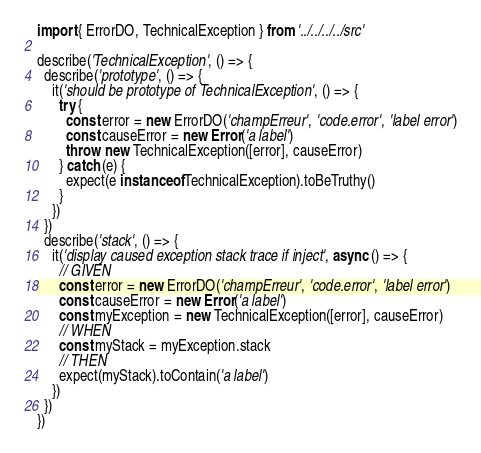<code> <loc_0><loc_0><loc_500><loc_500><_TypeScript_>import { ErrorDO, TechnicalException } from '../../../../src'

describe('TechnicalException', () => {
  describe('prototype', () => {
    it('should be prototype of TechnicalException', () => {
      try {
        const error = new ErrorDO('champErreur', 'code.error', 'label error')
        const causeError = new Error('a label')
        throw  new TechnicalException([error], causeError)
      } catch (e) {
        expect(e instanceof TechnicalException).toBeTruthy()
      }
    })
  })
  describe('stack', () => {
    it('display caused exception stack trace if inject', async () => {
      // GIVEN
      const error = new ErrorDO('champErreur', 'code.error', 'label error')
      const causeError = new Error('a label')
      const myException = new TechnicalException([error], causeError)
      // WHEN
      const myStack = myException.stack
      // THEN
      expect(myStack).toContain('a label')
    })
  })
})
</code> 